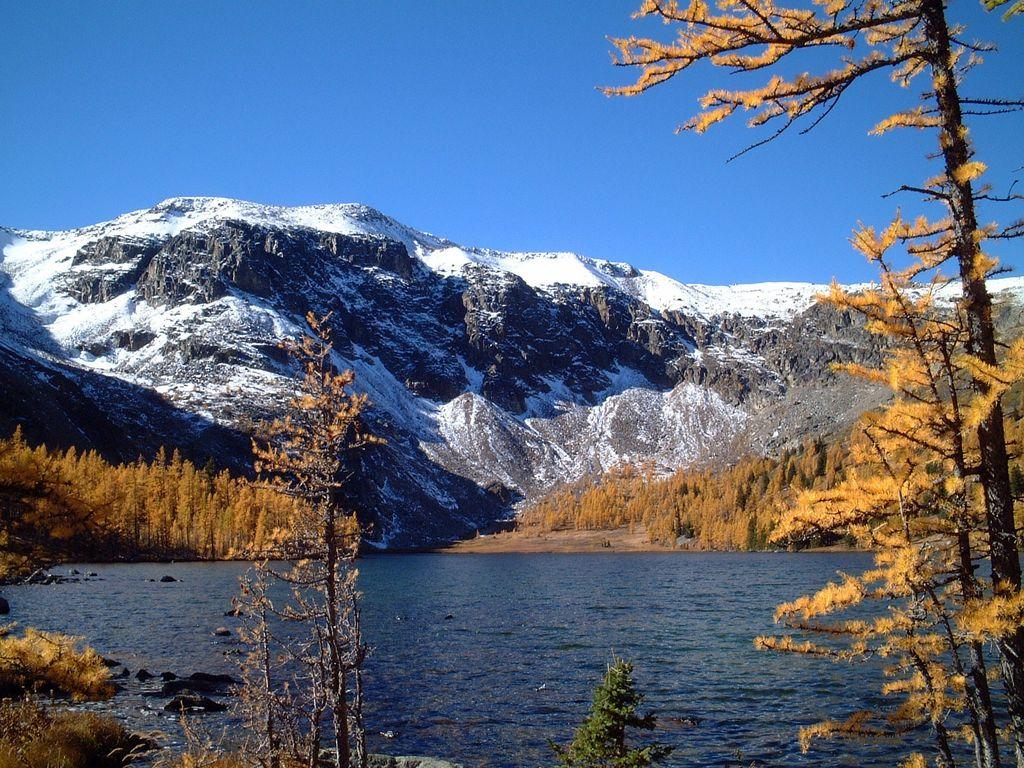What type of natural feature is the main subject of the image? There is a river in the image. What can be seen around the river? Trees and plants are present around the river. What is visible in the background of the image? There is a mountain and the sky in the background of the image. What type of treatment is being applied to the river in the image? There is no treatment being applied to the river in the image; it is a natural scene. 